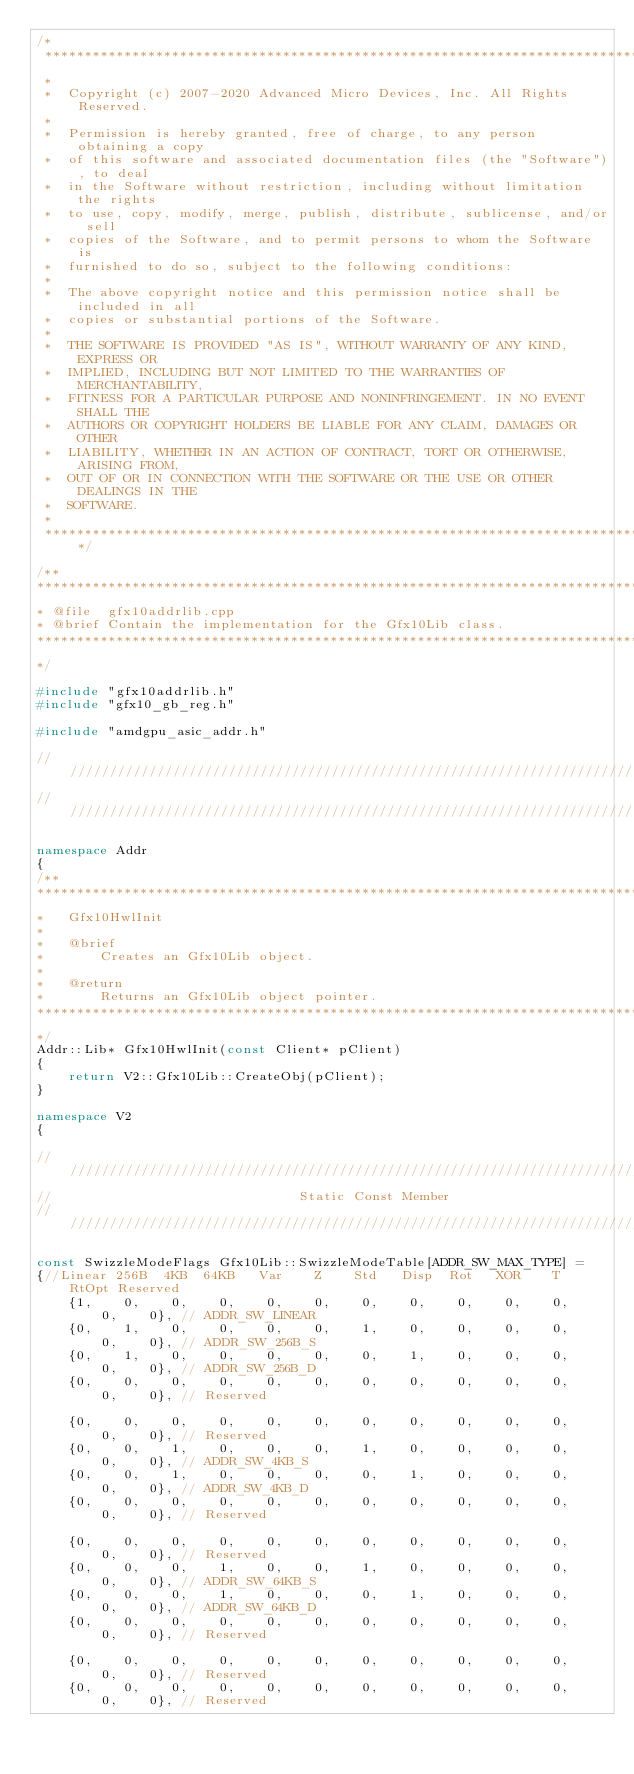Convert code to text. <code><loc_0><loc_0><loc_500><loc_500><_C++_>/*
 ***********************************************************************************************************************
 *
 *  Copyright (c) 2007-2020 Advanced Micro Devices, Inc. All Rights Reserved.
 *
 *  Permission is hereby granted, free of charge, to any person obtaining a copy
 *  of this software and associated documentation files (the "Software"), to deal
 *  in the Software without restriction, including without limitation the rights
 *  to use, copy, modify, merge, publish, distribute, sublicense, and/or sell
 *  copies of the Software, and to permit persons to whom the Software is
 *  furnished to do so, subject to the following conditions:
 *
 *  The above copyright notice and this permission notice shall be included in all
 *  copies or substantial portions of the Software.
 *
 *  THE SOFTWARE IS PROVIDED "AS IS", WITHOUT WARRANTY OF ANY KIND, EXPRESS OR
 *  IMPLIED, INCLUDING BUT NOT LIMITED TO THE WARRANTIES OF MERCHANTABILITY,
 *  FITNESS FOR A PARTICULAR PURPOSE AND NONINFRINGEMENT. IN NO EVENT SHALL THE
 *  AUTHORS OR COPYRIGHT HOLDERS BE LIABLE FOR ANY CLAIM, DAMAGES OR OTHER
 *  LIABILITY, WHETHER IN AN ACTION OF CONTRACT, TORT OR OTHERWISE, ARISING FROM,
 *  OUT OF OR IN CONNECTION WITH THE SOFTWARE OR THE USE OR OTHER DEALINGS IN THE
 *  SOFTWARE.
 *
 **********************************************************************************************************************/

/**
************************************************************************************************************************
* @file  gfx10addrlib.cpp
* @brief Contain the implementation for the Gfx10Lib class.
************************************************************************************************************************
*/

#include "gfx10addrlib.h"
#include "gfx10_gb_reg.h"

#include "amdgpu_asic_addr.h"

////////////////////////////////////////////////////////////////////////////////////////////////////////////////////////
////////////////////////////////////////////////////////////////////////////////////////////////////////////////////////

namespace Addr
{
/**
************************************************************************************************************************
*   Gfx10HwlInit
*
*   @brief
*       Creates an Gfx10Lib object.
*
*   @return
*       Returns an Gfx10Lib object pointer.
************************************************************************************************************************
*/
Addr::Lib* Gfx10HwlInit(const Client* pClient)
{
    return V2::Gfx10Lib::CreateObj(pClient);
}

namespace V2
{

////////////////////////////////////////////////////////////////////////////////////////////////////
//                               Static Const Member
////////////////////////////////////////////////////////////////////////////////////////////////////

const SwizzleModeFlags Gfx10Lib::SwizzleModeTable[ADDR_SW_MAX_TYPE] =
{//Linear 256B  4KB  64KB   Var    Z    Std   Disp  Rot   XOR    T     RtOpt Reserved
    {1,    0,    0,    0,    0,    0,    0,    0,    0,    0,    0,    0,    0}, // ADDR_SW_LINEAR
    {0,    1,    0,    0,    0,    0,    1,    0,    0,    0,    0,    0,    0}, // ADDR_SW_256B_S
    {0,    1,    0,    0,    0,    0,    0,    1,    0,    0,    0,    0,    0}, // ADDR_SW_256B_D
    {0,    0,    0,    0,    0,    0,    0,    0,    0,    0,    0,    0,    0}, // Reserved

    {0,    0,    0,    0,    0,    0,    0,    0,    0,    0,    0,    0,    0}, // Reserved
    {0,    0,    1,    0,    0,    0,    1,    0,    0,    0,    0,    0,    0}, // ADDR_SW_4KB_S
    {0,    0,    1,    0,    0,    0,    0,    1,    0,    0,    0,    0,    0}, // ADDR_SW_4KB_D
    {0,    0,    0,    0,    0,    0,    0,    0,    0,    0,    0,    0,    0}, // Reserved

    {0,    0,    0,    0,    0,    0,    0,    0,    0,    0,    0,    0,    0}, // Reserved
    {0,    0,    0,    1,    0,    0,    1,    0,    0,    0,    0,    0,    0}, // ADDR_SW_64KB_S
    {0,    0,    0,    1,    0,    0,    0,    1,    0,    0,    0,    0,    0}, // ADDR_SW_64KB_D
    {0,    0,    0,    0,    0,    0,    0,    0,    0,    0,    0,    0,    0}, // Reserved

    {0,    0,    0,    0,    0,    0,    0,    0,    0,    0,    0,    0,    0}, // Reserved
    {0,    0,    0,    0,    0,    0,    0,    0,    0,    0,    0,    0,    0}, // Reserved</code> 